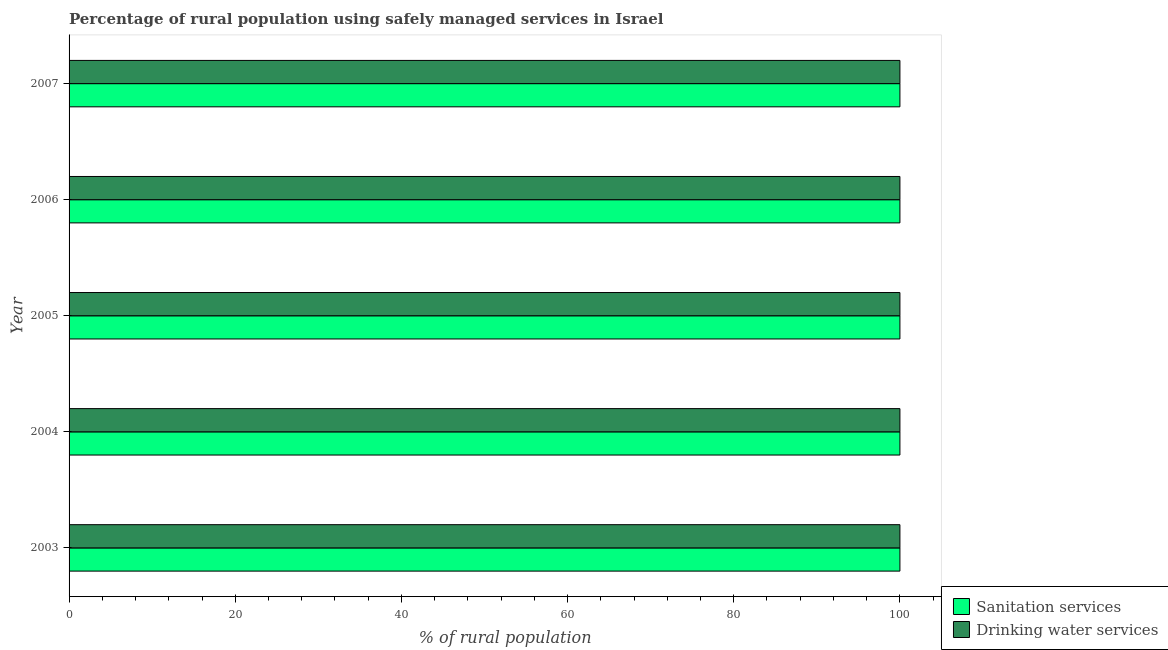Are the number of bars per tick equal to the number of legend labels?
Provide a short and direct response. Yes. How many bars are there on the 3rd tick from the top?
Your answer should be very brief. 2. What is the label of the 4th group of bars from the top?
Provide a short and direct response. 2004. What is the percentage of rural population who used drinking water services in 2007?
Provide a short and direct response. 100. Across all years, what is the maximum percentage of rural population who used sanitation services?
Offer a very short reply. 100. Across all years, what is the minimum percentage of rural population who used drinking water services?
Keep it short and to the point. 100. In which year was the percentage of rural population who used drinking water services maximum?
Provide a succinct answer. 2003. In which year was the percentage of rural population who used sanitation services minimum?
Provide a succinct answer. 2003. What is the total percentage of rural population who used drinking water services in the graph?
Give a very brief answer. 500. What is the difference between the percentage of rural population who used drinking water services in 2004 and the percentage of rural population who used sanitation services in 2005?
Offer a terse response. 0. What is the average percentage of rural population who used drinking water services per year?
Your answer should be very brief. 100. What is the ratio of the percentage of rural population who used sanitation services in 2004 to that in 2005?
Your answer should be very brief. 1. Is the percentage of rural population who used drinking water services in 2003 less than that in 2007?
Make the answer very short. No. What is the difference between the highest and the second highest percentage of rural population who used sanitation services?
Provide a succinct answer. 0. In how many years, is the percentage of rural population who used sanitation services greater than the average percentage of rural population who used sanitation services taken over all years?
Provide a succinct answer. 0. What does the 1st bar from the top in 2003 represents?
Your answer should be compact. Drinking water services. What does the 2nd bar from the bottom in 2006 represents?
Give a very brief answer. Drinking water services. How many bars are there?
Your response must be concise. 10. How many years are there in the graph?
Your response must be concise. 5. What is the difference between two consecutive major ticks on the X-axis?
Offer a terse response. 20. Are the values on the major ticks of X-axis written in scientific E-notation?
Give a very brief answer. No. Does the graph contain any zero values?
Ensure brevity in your answer.  No. Does the graph contain grids?
Offer a terse response. No. Where does the legend appear in the graph?
Your answer should be very brief. Bottom right. How many legend labels are there?
Your answer should be very brief. 2. What is the title of the graph?
Ensure brevity in your answer.  Percentage of rural population using safely managed services in Israel. Does "Private credit bureau" appear as one of the legend labels in the graph?
Provide a short and direct response. No. What is the label or title of the X-axis?
Keep it short and to the point. % of rural population. What is the label or title of the Y-axis?
Provide a short and direct response. Year. What is the % of rural population in Drinking water services in 2003?
Your response must be concise. 100. What is the % of rural population of Sanitation services in 2004?
Provide a short and direct response. 100. What is the % of rural population of Drinking water services in 2004?
Offer a terse response. 100. What is the % of rural population of Sanitation services in 2007?
Ensure brevity in your answer.  100. What is the % of rural population of Drinking water services in 2007?
Offer a terse response. 100. Across all years, what is the maximum % of rural population in Drinking water services?
Keep it short and to the point. 100. Across all years, what is the minimum % of rural population in Sanitation services?
Give a very brief answer. 100. Across all years, what is the minimum % of rural population of Drinking water services?
Ensure brevity in your answer.  100. What is the total % of rural population in Drinking water services in the graph?
Provide a short and direct response. 500. What is the difference between the % of rural population in Drinking water services in 2003 and that in 2006?
Offer a terse response. 0. What is the difference between the % of rural population of Drinking water services in 2003 and that in 2007?
Offer a very short reply. 0. What is the difference between the % of rural population of Sanitation services in 2004 and that in 2005?
Provide a short and direct response. 0. What is the difference between the % of rural population of Sanitation services in 2004 and that in 2006?
Ensure brevity in your answer.  0. What is the difference between the % of rural population of Drinking water services in 2004 and that in 2006?
Provide a short and direct response. 0. What is the difference between the % of rural population in Sanitation services in 2004 and that in 2007?
Offer a very short reply. 0. What is the difference between the % of rural population of Drinking water services in 2004 and that in 2007?
Provide a short and direct response. 0. What is the difference between the % of rural population in Drinking water services in 2005 and that in 2006?
Your response must be concise. 0. What is the difference between the % of rural population of Sanitation services in 2005 and that in 2007?
Provide a short and direct response. 0. What is the difference between the % of rural population of Sanitation services in 2003 and the % of rural population of Drinking water services in 2007?
Offer a terse response. 0. What is the difference between the % of rural population in Sanitation services in 2004 and the % of rural population in Drinking water services in 2005?
Keep it short and to the point. 0. What is the difference between the % of rural population of Sanitation services in 2004 and the % of rural population of Drinking water services in 2007?
Provide a succinct answer. 0. What is the difference between the % of rural population in Sanitation services in 2005 and the % of rural population in Drinking water services in 2007?
Provide a short and direct response. 0. What is the difference between the % of rural population in Sanitation services in 2006 and the % of rural population in Drinking water services in 2007?
Give a very brief answer. 0. What is the average % of rural population of Sanitation services per year?
Provide a short and direct response. 100. In the year 2005, what is the difference between the % of rural population of Sanitation services and % of rural population of Drinking water services?
Give a very brief answer. 0. In the year 2006, what is the difference between the % of rural population in Sanitation services and % of rural population in Drinking water services?
Provide a short and direct response. 0. What is the ratio of the % of rural population in Drinking water services in 2003 to that in 2005?
Your answer should be compact. 1. What is the ratio of the % of rural population of Sanitation services in 2003 to that in 2006?
Your answer should be compact. 1. What is the ratio of the % of rural population in Drinking water services in 2003 to that in 2007?
Give a very brief answer. 1. What is the ratio of the % of rural population in Sanitation services in 2004 to that in 2005?
Make the answer very short. 1. What is the ratio of the % of rural population in Drinking water services in 2004 to that in 2005?
Ensure brevity in your answer.  1. What is the ratio of the % of rural population of Sanitation services in 2005 to that in 2007?
Give a very brief answer. 1. What is the ratio of the % of rural population of Sanitation services in 2006 to that in 2007?
Give a very brief answer. 1. What is the difference between the highest and the second highest % of rural population in Drinking water services?
Your answer should be very brief. 0. What is the difference between the highest and the lowest % of rural population of Sanitation services?
Offer a very short reply. 0. What is the difference between the highest and the lowest % of rural population in Drinking water services?
Provide a succinct answer. 0. 